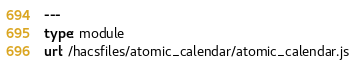Convert code to text. <code><loc_0><loc_0><loc_500><loc_500><_YAML_>---
type: module
url: /hacsfiles/atomic_calendar/atomic_calendar.js</code> 